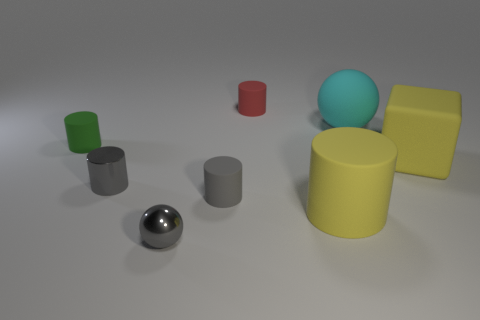What is the material of the block that is the same color as the big matte cylinder?
Your answer should be very brief. Rubber. How many other things are there of the same color as the large rubber ball?
Provide a succinct answer. 0. Is the tiny gray ball in front of the green matte cylinder made of the same material as the green cylinder?
Offer a terse response. No. What material is the sphere that is behind the tiny green rubber thing?
Offer a terse response. Rubber. There is a sphere in front of the tiny matte thing in front of the tiny green thing; what is its size?
Offer a terse response. Small. Is there a large yellow object that has the same material as the gray sphere?
Your response must be concise. No. There is a gray metallic object right of the small metal thing behind the ball in front of the big cyan thing; what is its shape?
Keep it short and to the point. Sphere. Is the color of the large object that is right of the cyan sphere the same as the small matte object that is behind the green thing?
Provide a succinct answer. No. Is there any other thing that has the same size as the gray metal cylinder?
Your answer should be compact. Yes. There is a large cyan matte thing; are there any tiny metallic cylinders in front of it?
Give a very brief answer. Yes. 